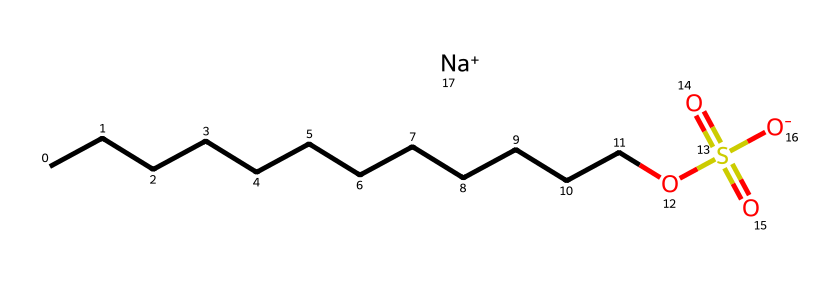What is the total number of carbon atoms in sodium lauryl sulfate? By examining the SMILES representation, "CCCCCCCCCCCC" indicates a continuous chain of 12 carbon atoms. Each "C" in the chain represents one carbon atom.
Answer: 12 How many oxygen atoms are present in sodium lauryl sulfate? The SMILES representation shows two distinct groups of oxygen atoms: one in "OS(=O)(=O)" which contains three oxygen atoms and one from the hydroxyl group "[O-]", totaling four oxygen atoms.
Answer: 4 What type of functional group does sodium lauryl sulfate contain? The presence of "OS(=O)(=O)" indicates a sulfate functional group (SO₄). This implies that the chemical structure has characteristics typical of sulfate esters.
Answer: sulfate How many total atoms are present in the chemical structure of sodium lauryl sulfate? The breakdown of the components counts 12 carbon atoms, 26 hydrogen atoms, 4 oxygen atoms, and 1 sodium atom, leading to a total count of 43 atoms (12 + 26 + 4 + 1 = 43).
Answer: 43 What is the role of sodium ion in sodium lauryl sulfate? The sodium ion (Na+) acts as a counterion to stabilize the negatively charged sulfate group, helping maintain the overall solubility and efficacy of the detergent in aqueous solutions.
Answer: counterion How does the long carbon chain affect the properties of sodium lauryl sulfate? The long hydrophobic carbon chain provides the surfactant properties, allowing sodium lauryl sulfate to reduce surface tension in water and effectively emulsify oils and dirt.
Answer: surfactant properties Why is sodium lauryl sulfate commonly used in hand soaps? Due to its effective surfactant properties derived from the combination of a hydrophobic carbon chain and a hydrophilic sulfate group, it is effective at removing dirt and grease, which is crucial in hand soaps.
Answer: effective cleaning agent 